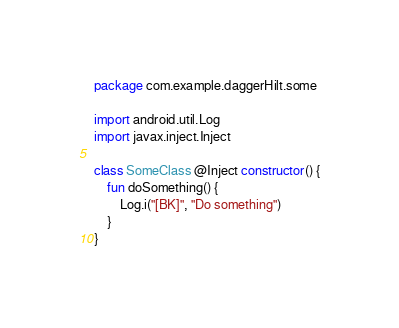Convert code to text. <code><loc_0><loc_0><loc_500><loc_500><_Kotlin_>package com.example.daggerHilt.some

import android.util.Log
import javax.inject.Inject

class SomeClass @Inject constructor() {
    fun doSomething() {
        Log.i("[BK]", "Do something")
    }
}</code> 